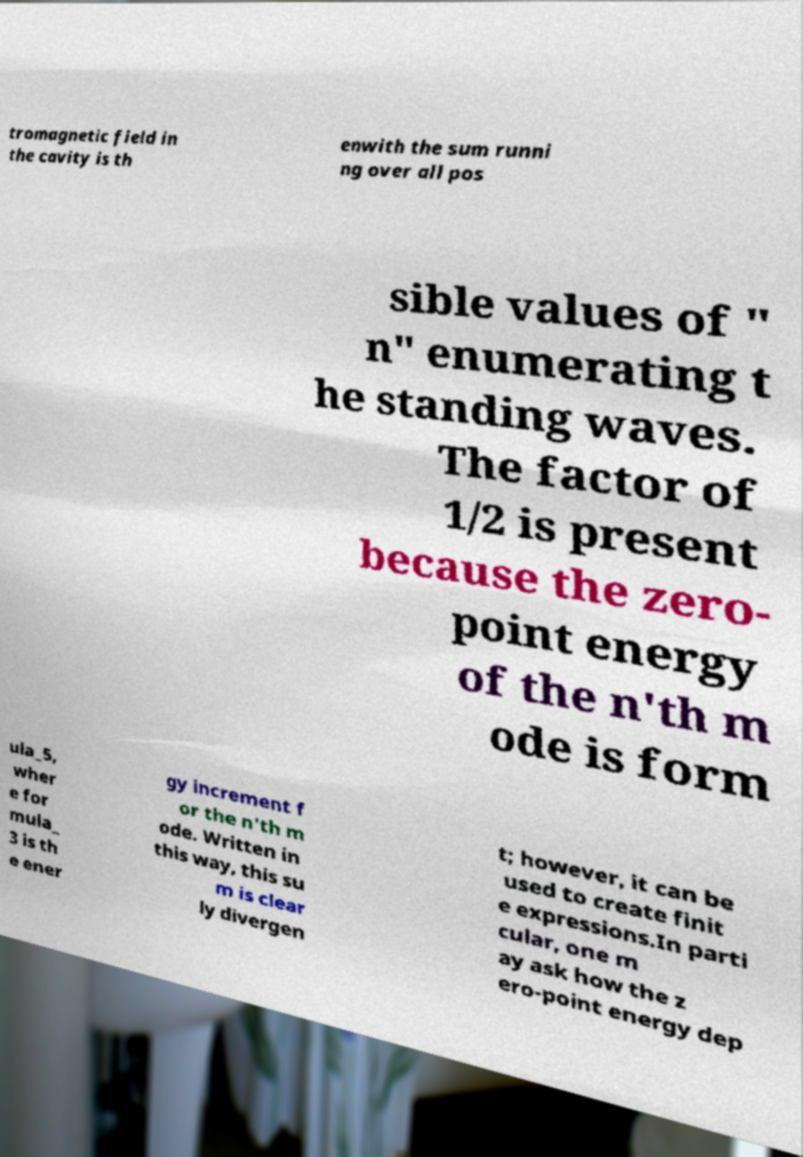Please identify and transcribe the text found in this image. tromagnetic field in the cavity is th enwith the sum runni ng over all pos sible values of " n" enumerating t he standing waves. The factor of 1/2 is present because the zero- point energy of the n'th m ode is form ula_5, wher e for mula_ 3 is th e ener gy increment f or the n'th m ode. Written in this way, this su m is clear ly divergen t; however, it can be used to create finit e expressions.In parti cular, one m ay ask how the z ero-point energy dep 